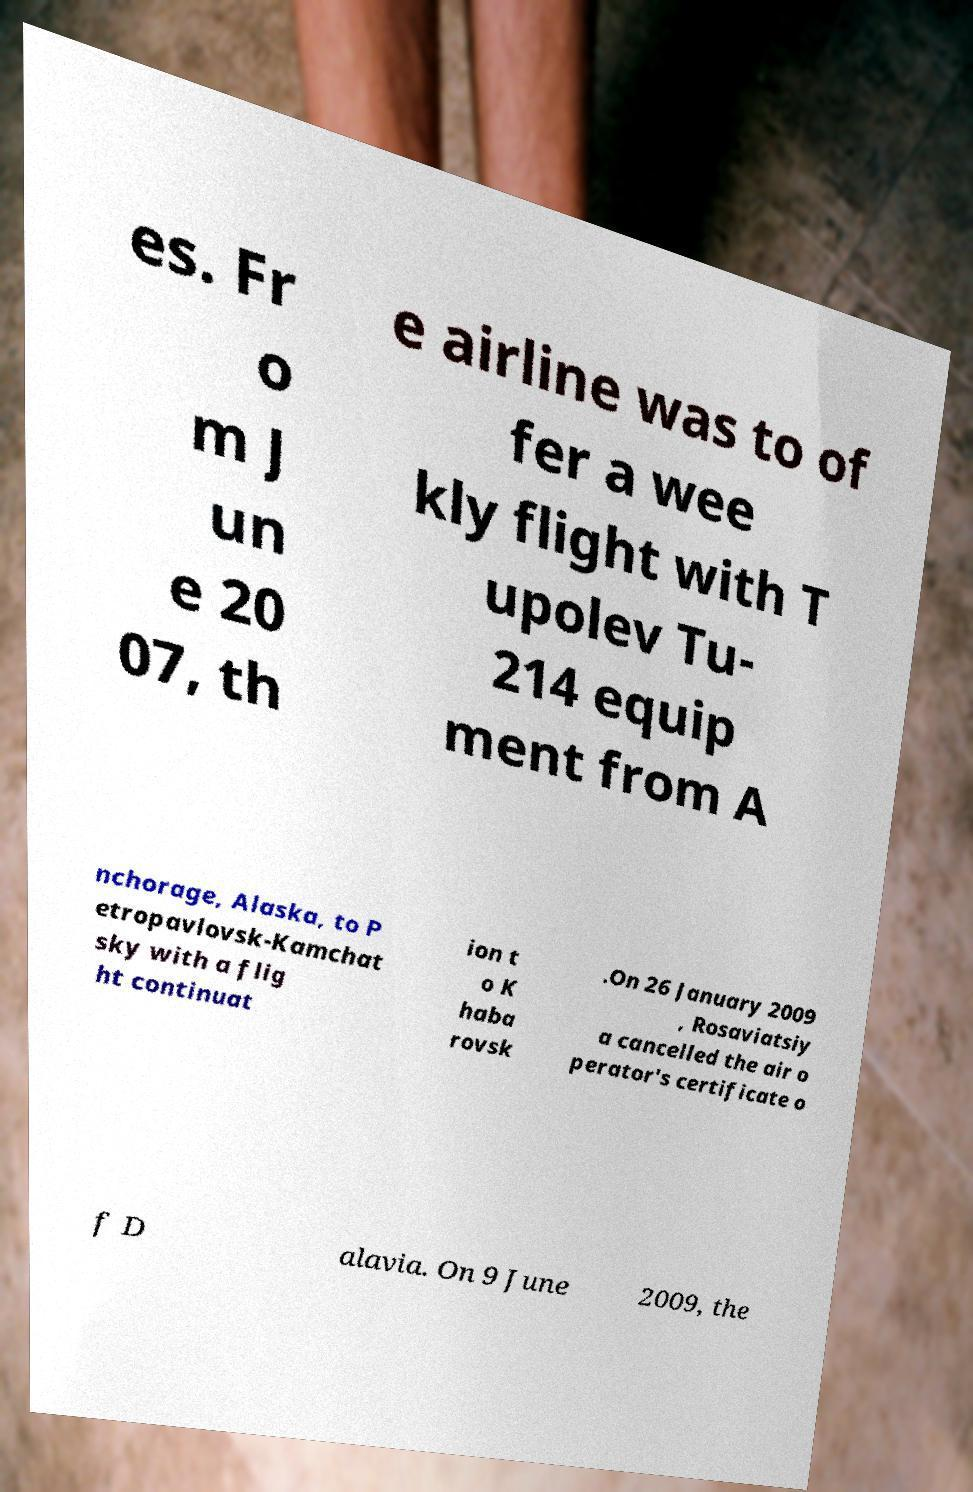Could you assist in decoding the text presented in this image and type it out clearly? es. Fr o m J un e 20 07, th e airline was to of fer a wee kly flight with T upolev Tu- 214 equip ment from A nchorage, Alaska, to P etropavlovsk-Kamchat sky with a flig ht continuat ion t o K haba rovsk .On 26 January 2009 , Rosaviatsiy a cancelled the air o perator's certificate o f D alavia. On 9 June 2009, the 